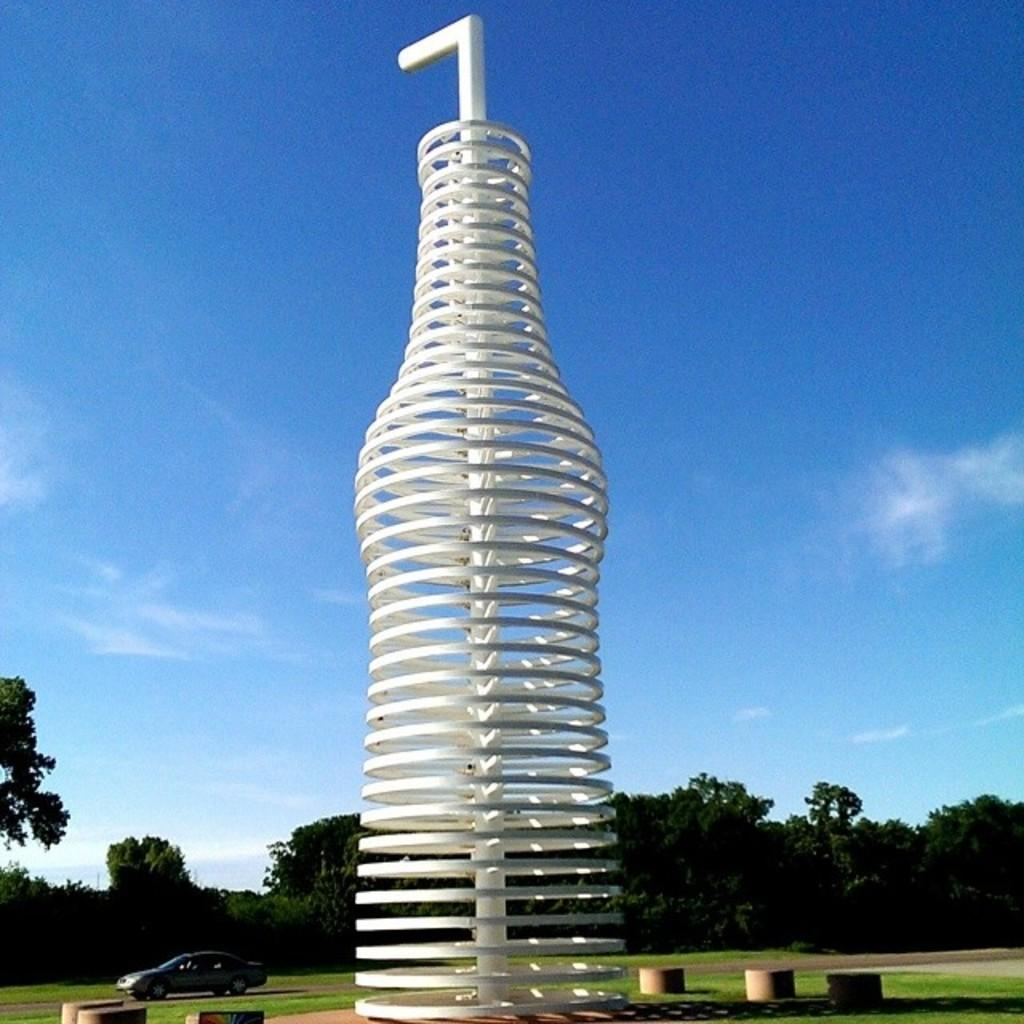What is the main structure in the image? There is a white color structure in the image. What else can be seen in the background of the image? There is a vehicle and trees with green color in the background of the image. How would you describe the sky in the image? The sky is blue and white in color. How many clocks are hanging on the trees in the image? There are no clocks hanging on the trees in the image. 